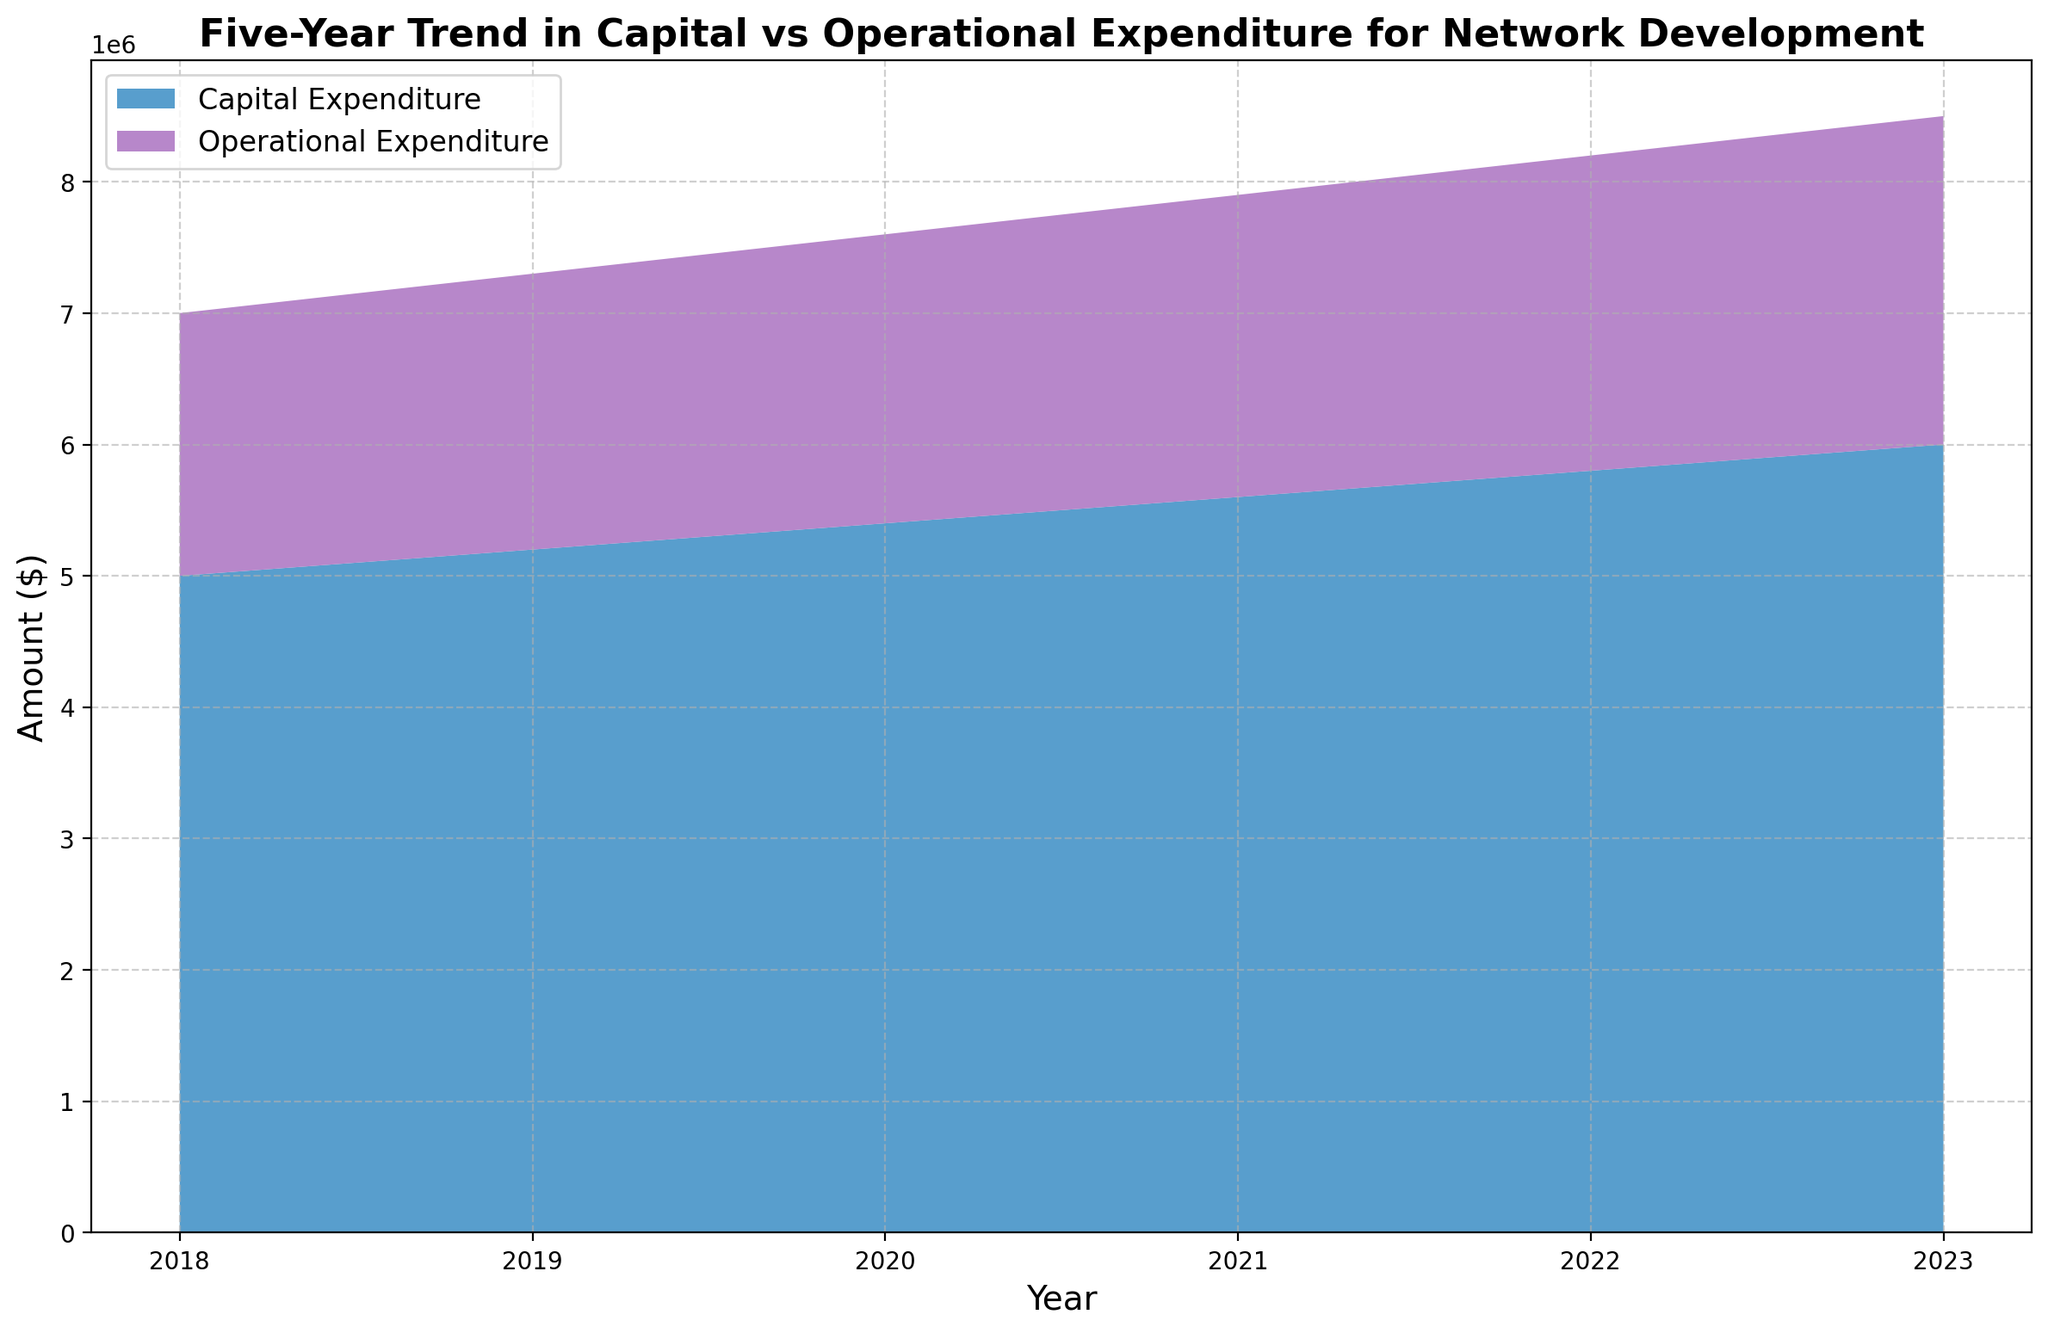What's the trend in Capital Expenditure from 2018 to 2023? Looking at the area chart, Capital Expenditure consistently increases each year from 2018 to 2023. The amount spent on Capital Expenditure starts at $5,000,000 in 2018 and increases by $200,000 each year, reaching $6,000,000 in 2023.
Answer: It shows an increasing trend How does Operational Expenditure in 2023 compare to that in 2018? From the chart, the Operational Expenditure in 2018 is $2,000,000, and in 2023 it is $2,500,000. This shows an increase of $500,000 over the five-year period.
Answer: It increased by $500,000 Which category, Capital or Operational Expenditure, shows a more rapid increase over the years? By examining the slope and area of each expenditure category, both Capital and Operational Expenditures increase over the years. However, Capital Expenditure starts higher and also increases by $1,000,000 over the five-year span, while Operational Expenditure increases by $500,000.
Answer: Capital Expenditure What is the total expenditure in 2020? To find the total expenditure in 2020, add the Capital Expenditure ($5,400,000) and Operational Expenditure ($2,200,000). This gives $5,400,000 + $2,200,000 = $7,600,000.
Answer: $7,600,000 By how much did the Capital Expenditure increase from 2019 to 2020? The Capital Expenditure in 2019 is $5,200,000, and in 2020 it is $5,400,000. The increase is calculated as $5,400,000 - $5,200,000 = $200,000.
Answer: $200,000 What is the combined total expenditure (Capital + Operational) over the five-year period? To find the combined total expenditure, we need to sum both Capital and Operational Expenditures for each year and then add these yearly totals. This gives: (5,000,000 + 2,000,000) + (5,200,000 + 2,100,000) + (5,400,000 + 2,200,000) + (5,600,000 + 2,300,000) + (5,800,000 + 2,400,000) + (6,000,000 + 2,500,000) = 31,500,000.
Answer: $31,500,000 What pattern do you observe in the difference between Capital and Operational Expenditures over the years? The difference between Capital and Operational Expenditures remains consistent over the years. Each year, Capital Expenditure is consistently $3,000,000 more than Operational Expenditure.
Answer: Consistent $3,000,000 difference How does the growth rate of Operational Expenditure compare to the growth rate of Capital Expenditure? Operational Expenditure increases by $100,000 each year, while Capital Expenditure increases by $200,000 each year. Thus, the growth rate of Capital Expenditure is double that of Operational Expenditure.
Answer: Capital Expenditure grows faster 